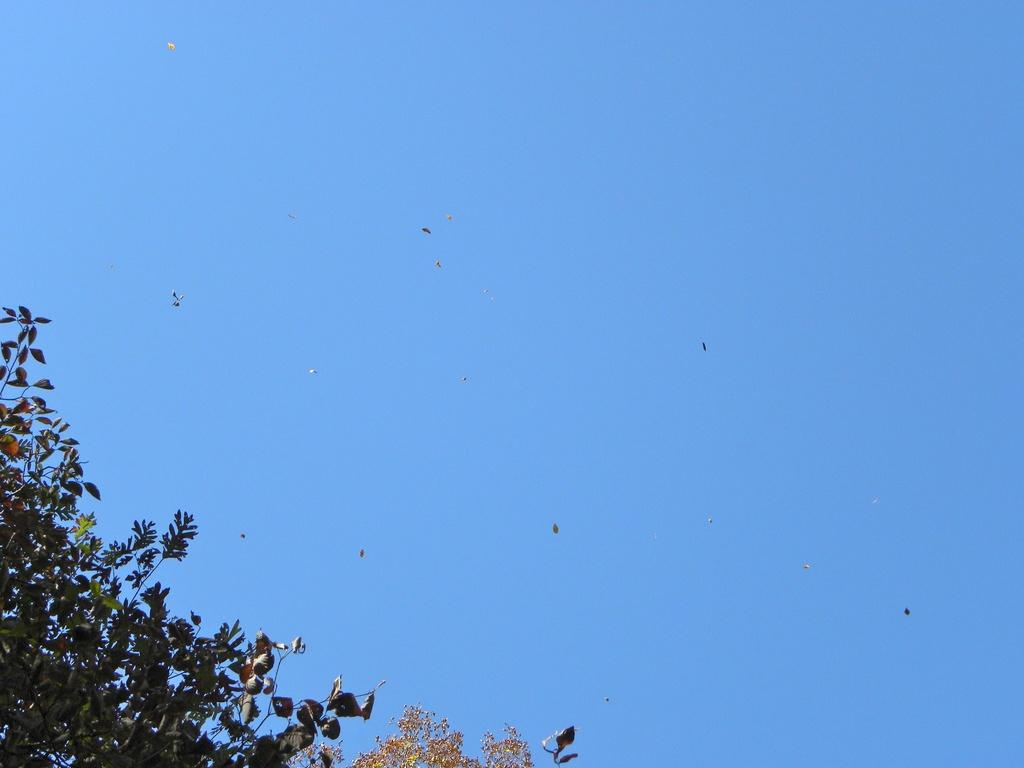What part of the natural environment can be seen in the image? The sky is visible in the image. What type of vegetation is present at the bottom of the image? Tree leaves with stems are present at the bottom of the image. What type of library can be seen in the image? There is no library present in the image; it only features the sky and tree leaves with stems. How many quarters are visible in the image? There are no quarters present in the image. 